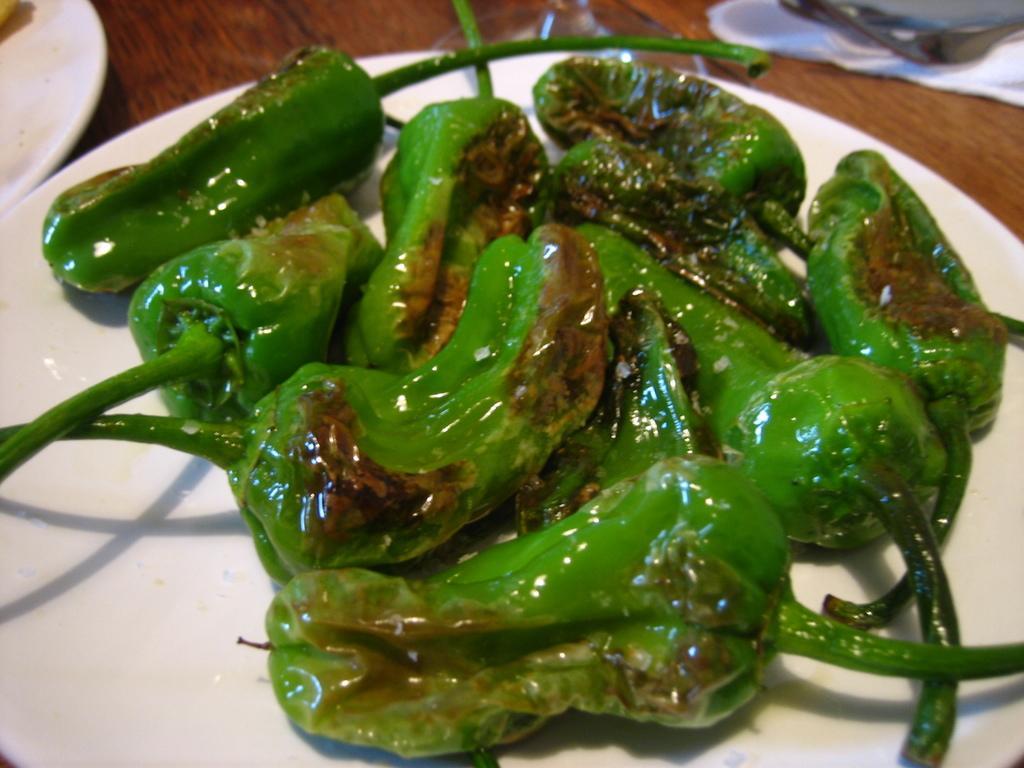Can you describe this image briefly? In this image, we can see some food item in a plate. We can see a white colored object in the top left corner. We can also see some objects in the top right corner. 